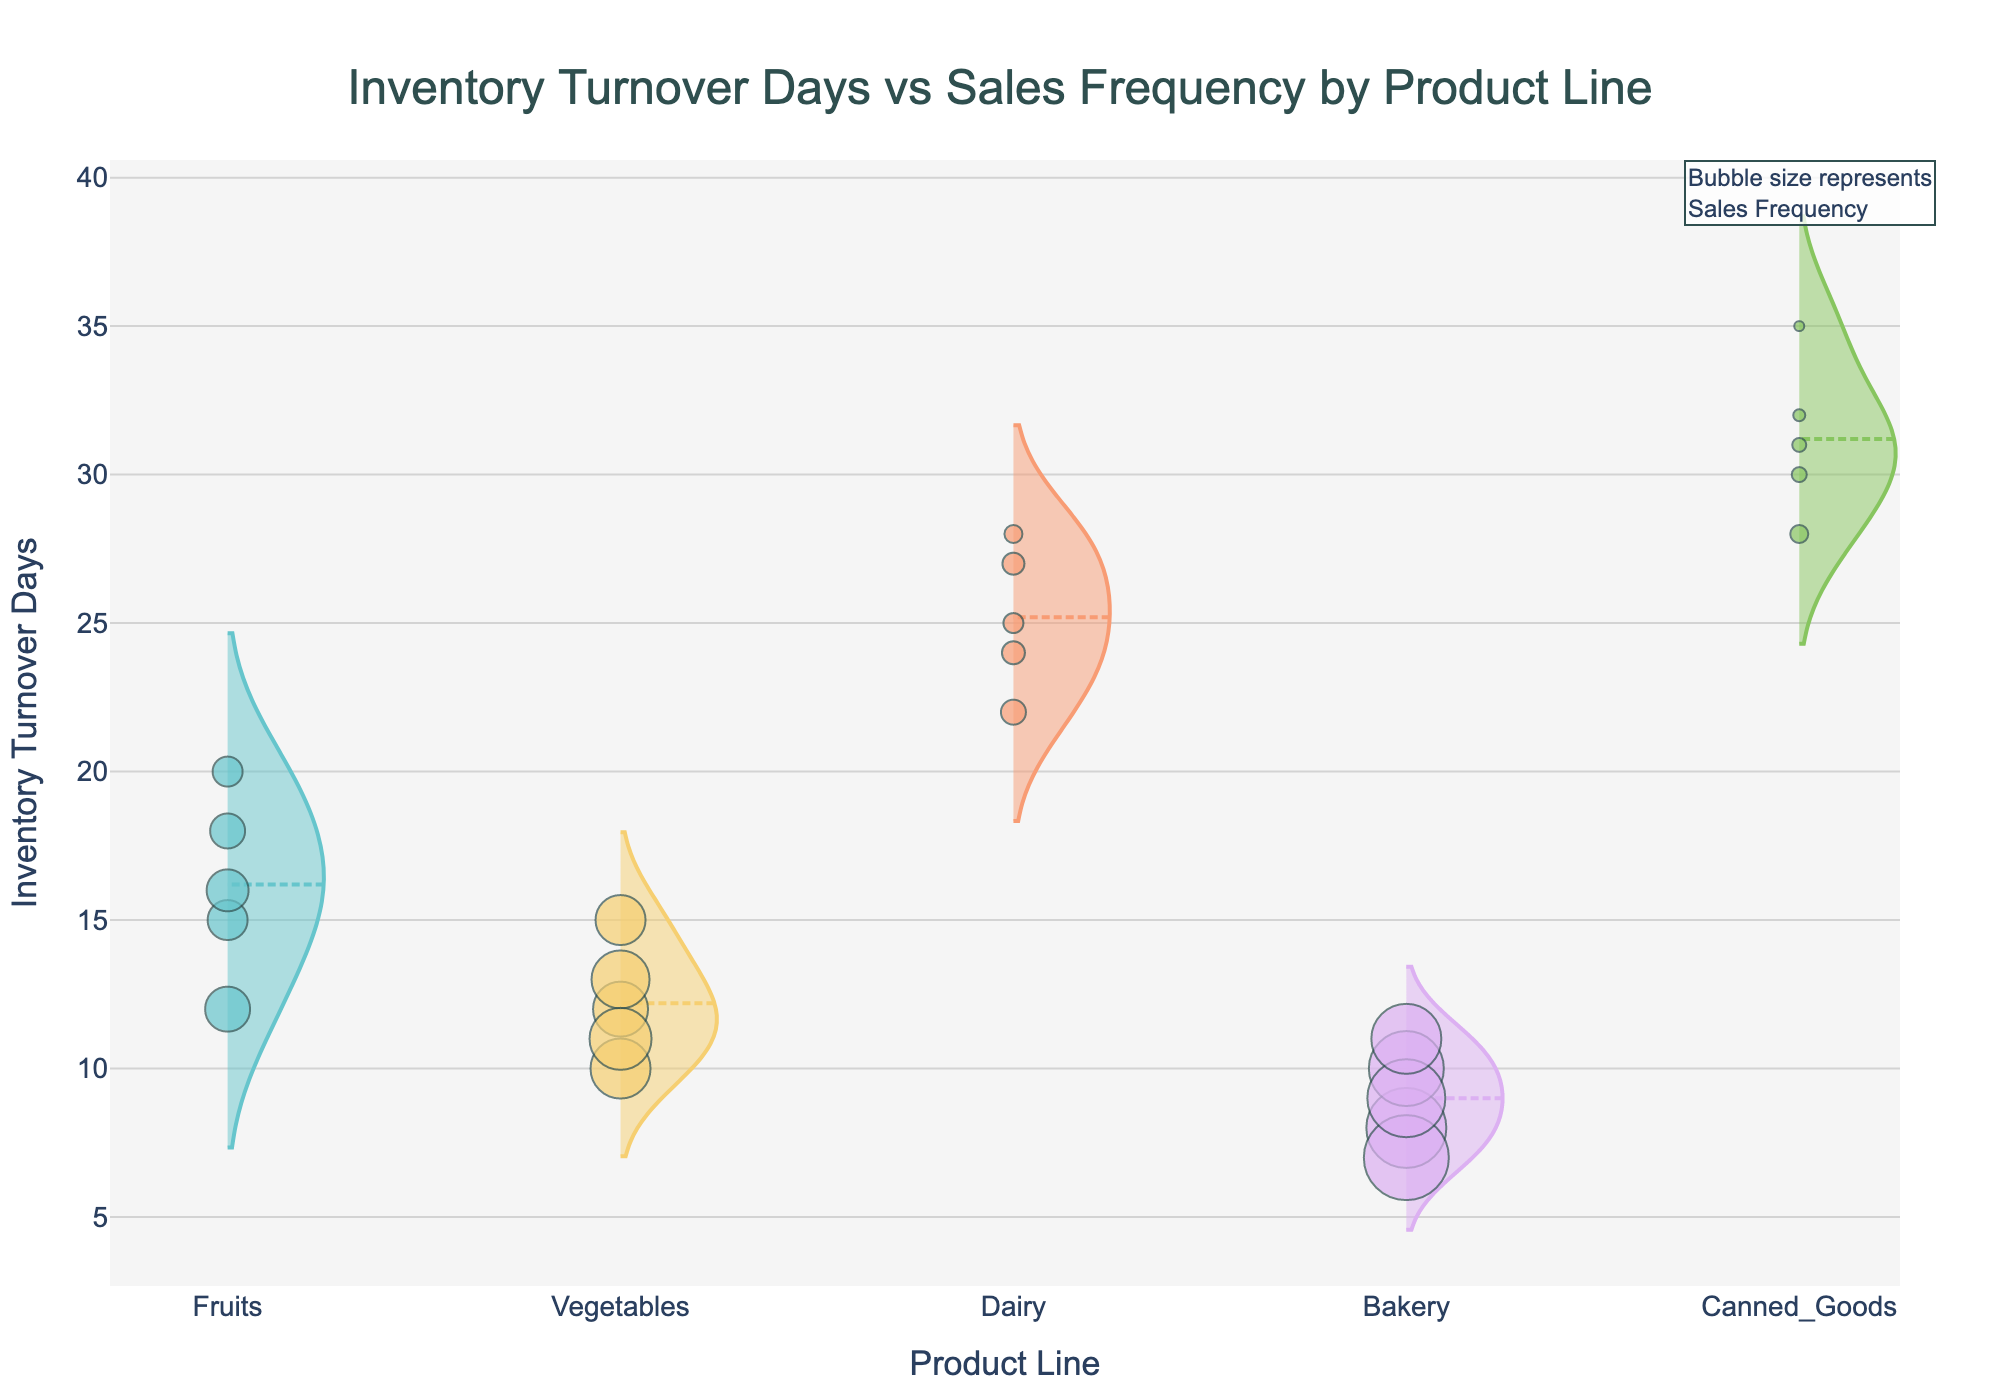what is the product line with the longest average inventory turnover days? The longest average inventory turnover days can be identified by looking for the thickest part of the violin plot nearest to the top of the y-axis. For this figure, the product line "Canned_Goods" shows the highest average inventory turnover days.
Answer: Canned_Goods which product line has the highest sales frequency for its data points? The highest sales frequency is denoted by the largest sized points in the scatter plot. The product line "Bakery" has the largest points, indicating the highest sales frequency.
Answer: Bakery compare inventory turnover days between Fruits and Dairy. Which one is generally higher? By comparing the relative heights and thicknesses of the violin plots for Fruits and Dairy, it is clear that Dairy generally has higher inventory turnover days than Fruits.
Answer: Dairy what is the median inventory turnover days for Vegetables? The median value is indicated by the horizontal white line within the violin plot for Vegetables, appearing around the number 12.
Answer: 12 how do average inventory turnover days for Fruits and Bakery compare? By comparing the central horizontal lines (representing the mean) in both Fruits and Bakery violin plots, it is evident that Bakery has lower average inventory turnover days compared to Fruits.
Answer: Bakery what is the range of inventory turnover days for Dairy? The range can be determined by looking at the lowest and highest points within the Dairy violin plot. The Dairy has a range from 22 to 28 days.
Answer: 22-28 which product line has the most consistent inventory turnover days? The product line with the least variance is identified by the narrowest violin plot. "Dairy" has the most consistent inventory turnover days as its violin plot is relatively narrow.
Answer: Dairy are there any outliers visible in the plot? Outliers would appear as points distant from the bulk of the data within the violin plots. There don't appear to be any significant outliers in any of the product lines from this plot.
Answer: No does any product line have very low inventory turnover days? By looking at the lowest points of the violin plots, "Bakery" has inventory turnover days as low as 7 days, which is relatively very low.
Answer: Bakery 